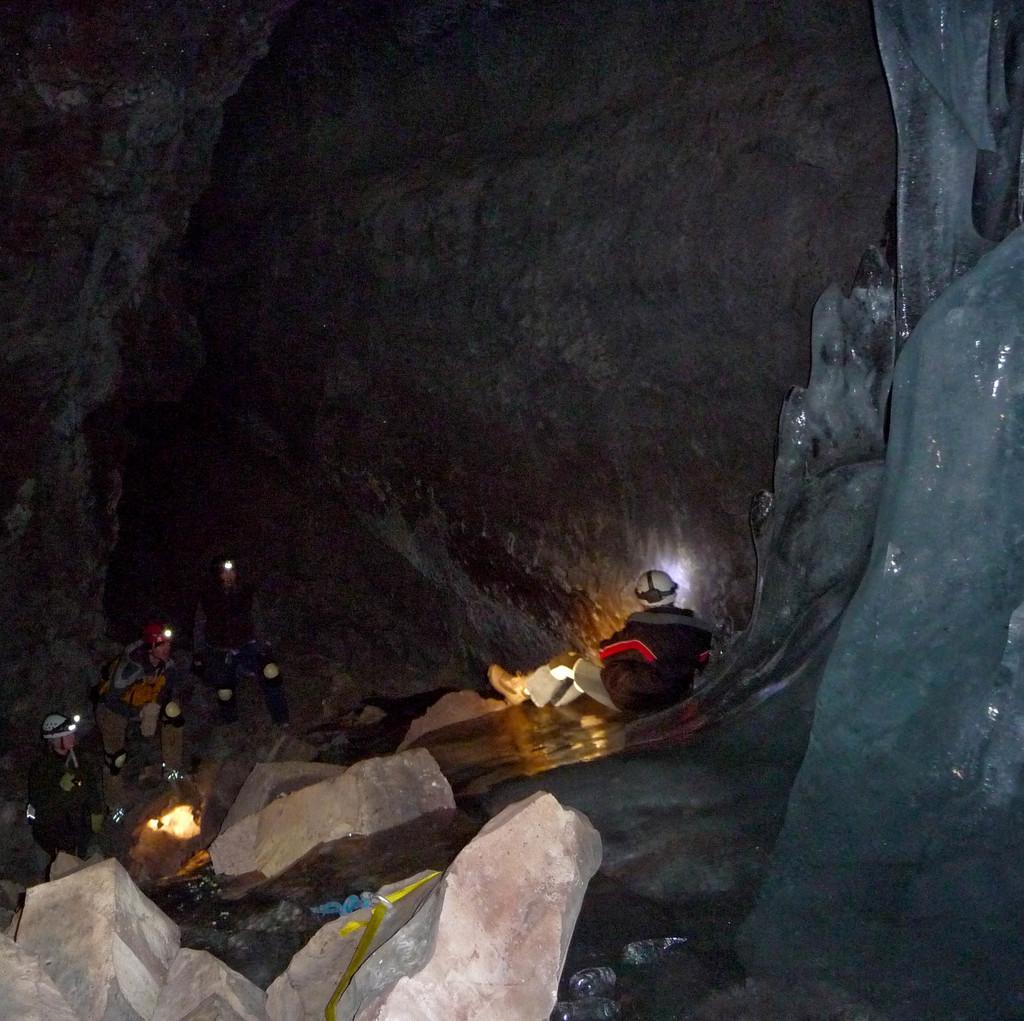Please provide a concise description of this image. In this image, we can see a cave. There are a few people and rocks. 